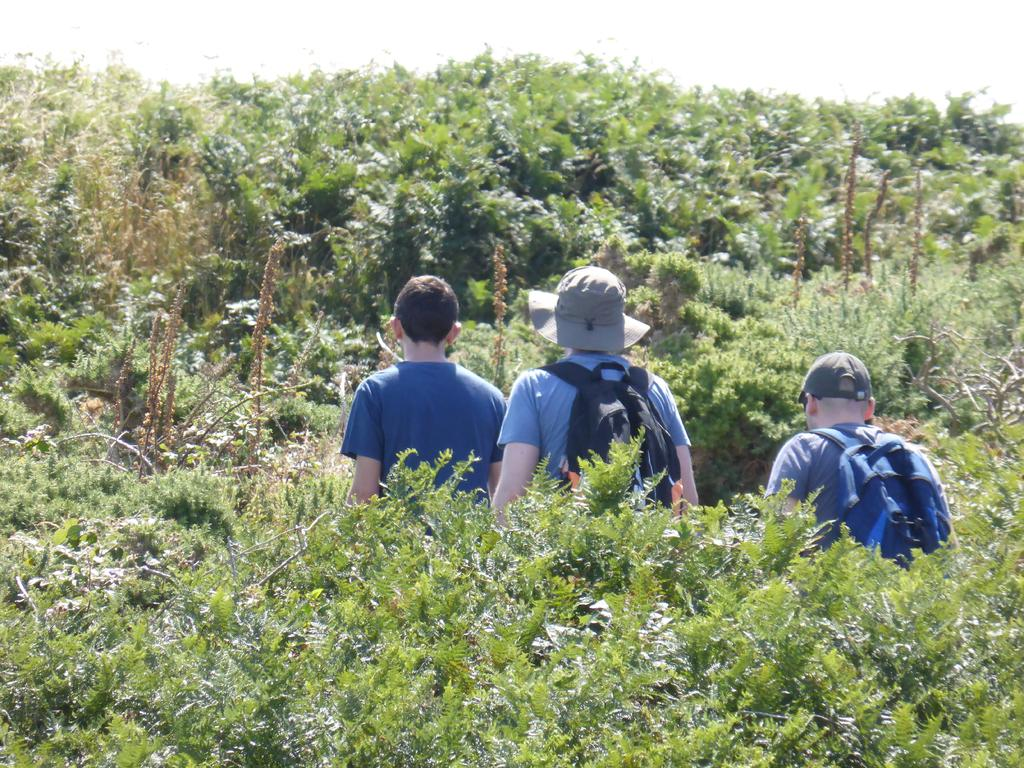What type of plants can be seen on the ground in the image? There are plants with green leaves on the ground in the image. Can you describe the people in the background? There are three persons in the background of the image. What else can be seen on the ground in the background? There are plants and trees on the ground in the background. What is visible in the sky in the image? There are clouds in the sky in the image. Can you tell me how many tigers are hiding in the plants in the image? There are no tigers present in the image; it features plants with green leaves on the ground. What type of poison is being used by the plants in the image? There is no mention of poison in the image; the plants have green leaves and are not described as poisonous. 